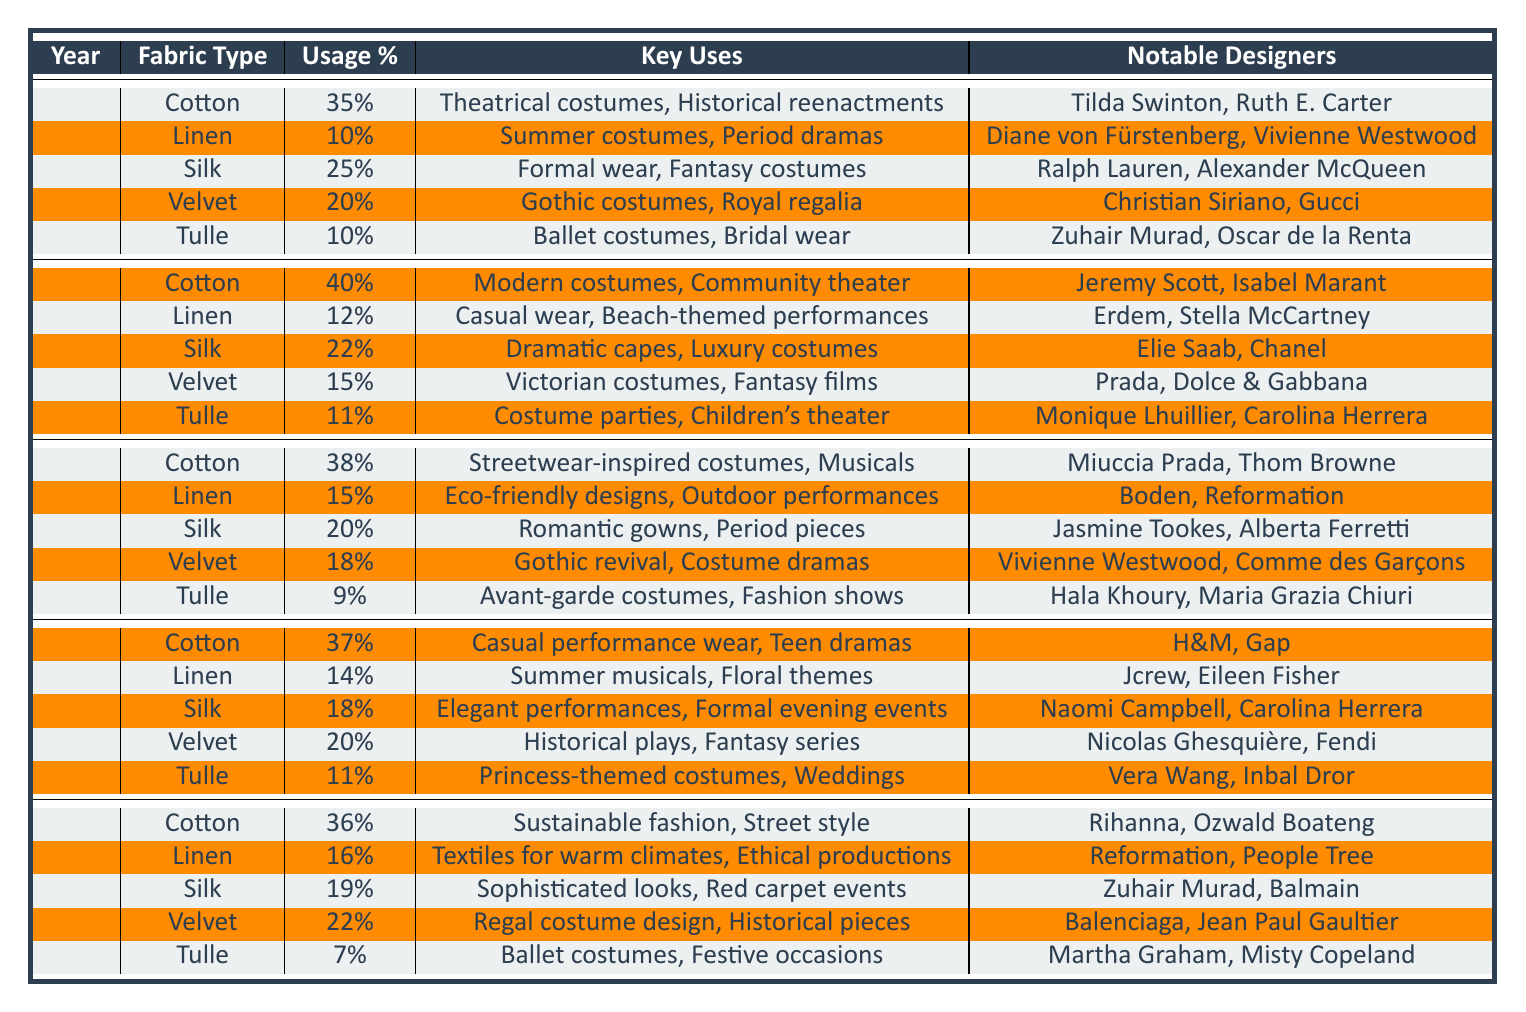What was the most used fabric type in 2019? By examining the usage percentages in 2019, we see that Cotton had the highest usage percentage at 35%.
Answer: Cotton Which fabric saw an increase in usage percentage from 2019 to 2020? Comparing the usage percentages for each fabric type between 2019 and 2020, Cotton increased from 35% to 40%, which is an increase.
Answer: Cotton Is Tulle used more in 2023 or in 2022? Looking at the usage percentages, Tulle was used 11% in 2022 and decreased to 7% in 2023, indicating it is used less in 2023.
Answer: 2022 What is the total usage percentage of Cotton across all years? Summing the usage percentages for Cotton: 35% (2019) + 40% (2020) + 38% (2021) + 37% (2022) + 36% (2023) = 186%.
Answer: 186% Which year had the lowest usage percentage of Silk? Analyzing the usage percentages for Silk across the years, the lowest was in 2023 at 19%.
Answer: 2023 Did Velvet have a higher percentage of usage in 2023 than in 2022? Velvet's usage in 2023 is 22%, compared to 20% in 2022, which indicates that Velvet had a higher usage percentage in 2023.
Answer: Yes What are the key uses of Cotton in 2021? The table shows that Cotton was key for streetwear-inspired costumes and musicals in 2021.
Answer: Streetwear-inspired costumes, Musicals What fabric type consistently had a usage percentage of around 10% across most years? Looking through the table, Tulle maintained a usage percentage around 10% in several years, as it was 10% in 2019, 11% in 2020, and 11% in 2022, but dropped to 7% in 2023.
Answer: Tulle Which fabric type did not see a significant fluctuation in usage percentage across the years? Linen shows relatively consistent percentages, with values between 10% and 16% across all the years, indicating it did not have dramatic changes.
Answer: Linen 